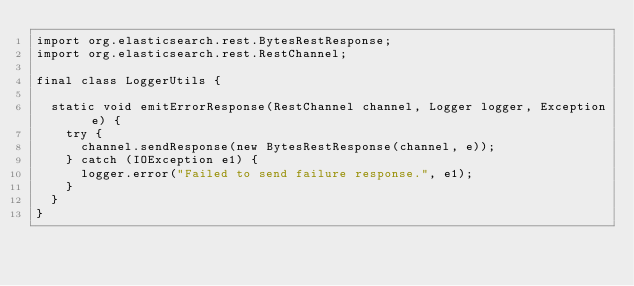<code> <loc_0><loc_0><loc_500><loc_500><_Java_>import org.elasticsearch.rest.BytesRestResponse;
import org.elasticsearch.rest.RestChannel;

final class LoggerUtils {

  static void emitErrorResponse(RestChannel channel, Logger logger, Exception e) {
    try {
      channel.sendResponse(new BytesRestResponse(channel, e));
    } catch (IOException e1) {
      logger.error("Failed to send failure response.", e1);
    }
  }
}
</code> 